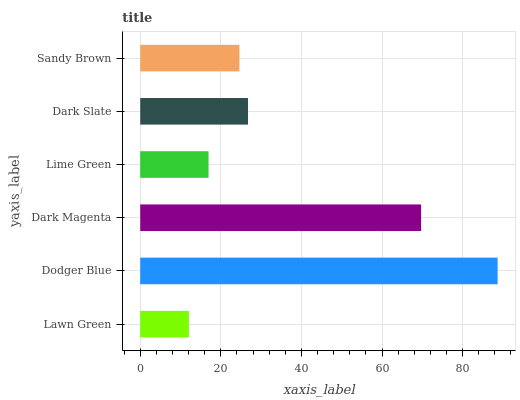Is Lawn Green the minimum?
Answer yes or no. Yes. Is Dodger Blue the maximum?
Answer yes or no. Yes. Is Dark Magenta the minimum?
Answer yes or no. No. Is Dark Magenta the maximum?
Answer yes or no. No. Is Dodger Blue greater than Dark Magenta?
Answer yes or no. Yes. Is Dark Magenta less than Dodger Blue?
Answer yes or no. Yes. Is Dark Magenta greater than Dodger Blue?
Answer yes or no. No. Is Dodger Blue less than Dark Magenta?
Answer yes or no. No. Is Dark Slate the high median?
Answer yes or no. Yes. Is Sandy Brown the low median?
Answer yes or no. Yes. Is Dodger Blue the high median?
Answer yes or no. No. Is Dark Magenta the low median?
Answer yes or no. No. 